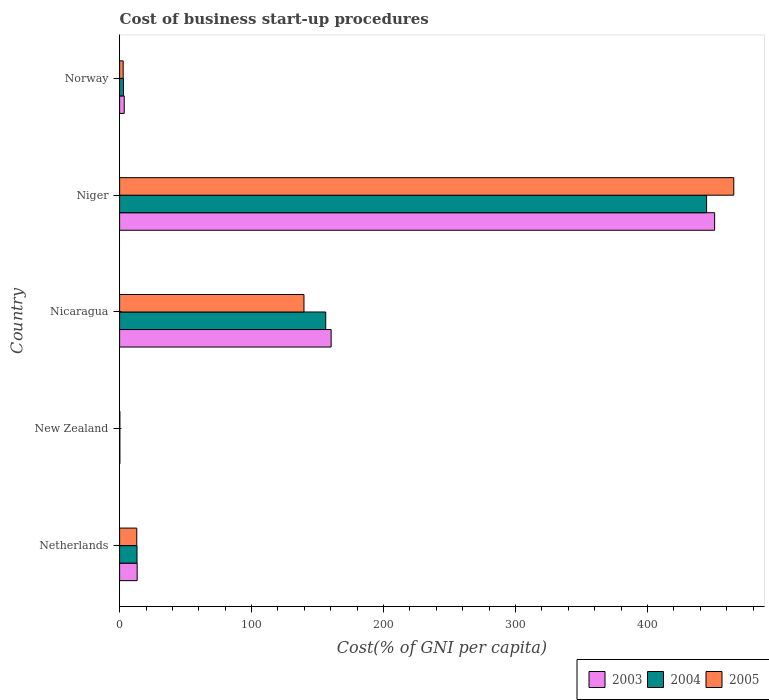How many groups of bars are there?
Make the answer very short. 5. Are the number of bars per tick equal to the number of legend labels?
Your answer should be very brief. Yes. How many bars are there on the 1st tick from the top?
Your answer should be very brief. 3. How many bars are there on the 5th tick from the bottom?
Provide a succinct answer. 3. What is the label of the 2nd group of bars from the top?
Your response must be concise. Niger. What is the cost of business start-up procedures in 2005 in Nicaragua?
Your answer should be compact. 139.7. Across all countries, what is the maximum cost of business start-up procedures in 2005?
Ensure brevity in your answer.  465.4. In which country was the cost of business start-up procedures in 2005 maximum?
Your answer should be compact. Niger. In which country was the cost of business start-up procedures in 2004 minimum?
Keep it short and to the point. New Zealand. What is the total cost of business start-up procedures in 2003 in the graph?
Give a very brief answer. 628.2. What is the difference between the cost of business start-up procedures in 2003 in Netherlands and that in Nicaragua?
Provide a short and direct response. -147. What is the difference between the cost of business start-up procedures in 2004 in New Zealand and the cost of business start-up procedures in 2005 in Nicaragua?
Provide a succinct answer. -139.5. What is the average cost of business start-up procedures in 2003 per country?
Make the answer very short. 125.64. What is the difference between the cost of business start-up procedures in 2003 and cost of business start-up procedures in 2005 in Norway?
Offer a very short reply. 0.8. What is the ratio of the cost of business start-up procedures in 2005 in Nicaragua to that in Norway?
Your response must be concise. 51.74. Is the cost of business start-up procedures in 2005 in Nicaragua less than that in Norway?
Offer a terse response. No. What is the difference between the highest and the second highest cost of business start-up procedures in 2005?
Make the answer very short. 325.7. What is the difference between the highest and the lowest cost of business start-up procedures in 2005?
Make the answer very short. 465.2. Is it the case that in every country, the sum of the cost of business start-up procedures in 2004 and cost of business start-up procedures in 2003 is greater than the cost of business start-up procedures in 2005?
Make the answer very short. Yes. How many bars are there?
Offer a very short reply. 15. What is the difference between two consecutive major ticks on the X-axis?
Offer a terse response. 100. Are the values on the major ticks of X-axis written in scientific E-notation?
Make the answer very short. No. Does the graph contain grids?
Your answer should be very brief. No. What is the title of the graph?
Provide a succinct answer. Cost of business start-up procedures. What is the label or title of the X-axis?
Give a very brief answer. Cost(% of GNI per capita). What is the label or title of the Y-axis?
Provide a succinct answer. Country. What is the Cost(% of GNI per capita) in 2003 in Netherlands?
Provide a succinct answer. 13.3. What is the Cost(% of GNI per capita) of 2003 in Nicaragua?
Ensure brevity in your answer.  160.3. What is the Cost(% of GNI per capita) of 2004 in Nicaragua?
Give a very brief answer. 156.2. What is the Cost(% of GNI per capita) in 2005 in Nicaragua?
Your answer should be very brief. 139.7. What is the Cost(% of GNI per capita) in 2003 in Niger?
Offer a terse response. 450.9. What is the Cost(% of GNI per capita) of 2004 in Niger?
Make the answer very short. 444.8. What is the Cost(% of GNI per capita) of 2005 in Niger?
Provide a short and direct response. 465.4. What is the Cost(% of GNI per capita) in 2003 in Norway?
Offer a very short reply. 3.5. Across all countries, what is the maximum Cost(% of GNI per capita) of 2003?
Ensure brevity in your answer.  450.9. Across all countries, what is the maximum Cost(% of GNI per capita) of 2004?
Your answer should be very brief. 444.8. Across all countries, what is the maximum Cost(% of GNI per capita) of 2005?
Your response must be concise. 465.4. Across all countries, what is the minimum Cost(% of GNI per capita) in 2003?
Offer a very short reply. 0.2. Across all countries, what is the minimum Cost(% of GNI per capita) in 2004?
Provide a short and direct response. 0.2. Across all countries, what is the minimum Cost(% of GNI per capita) in 2005?
Give a very brief answer. 0.2. What is the total Cost(% of GNI per capita) in 2003 in the graph?
Provide a short and direct response. 628.2. What is the total Cost(% of GNI per capita) of 2004 in the graph?
Your answer should be very brief. 617.3. What is the total Cost(% of GNI per capita) in 2005 in the graph?
Your answer should be compact. 621. What is the difference between the Cost(% of GNI per capita) in 2003 in Netherlands and that in New Zealand?
Your answer should be very brief. 13.1. What is the difference between the Cost(% of GNI per capita) of 2005 in Netherlands and that in New Zealand?
Offer a terse response. 12.8. What is the difference between the Cost(% of GNI per capita) of 2003 in Netherlands and that in Nicaragua?
Offer a very short reply. -147. What is the difference between the Cost(% of GNI per capita) of 2004 in Netherlands and that in Nicaragua?
Your answer should be compact. -143. What is the difference between the Cost(% of GNI per capita) of 2005 in Netherlands and that in Nicaragua?
Offer a very short reply. -126.7. What is the difference between the Cost(% of GNI per capita) in 2003 in Netherlands and that in Niger?
Make the answer very short. -437.6. What is the difference between the Cost(% of GNI per capita) in 2004 in Netherlands and that in Niger?
Your answer should be compact. -431.6. What is the difference between the Cost(% of GNI per capita) in 2005 in Netherlands and that in Niger?
Provide a succinct answer. -452.4. What is the difference between the Cost(% of GNI per capita) in 2004 in Netherlands and that in Norway?
Provide a succinct answer. 10.3. What is the difference between the Cost(% of GNI per capita) in 2003 in New Zealand and that in Nicaragua?
Your answer should be compact. -160.1. What is the difference between the Cost(% of GNI per capita) of 2004 in New Zealand and that in Nicaragua?
Make the answer very short. -156. What is the difference between the Cost(% of GNI per capita) in 2005 in New Zealand and that in Nicaragua?
Offer a very short reply. -139.5. What is the difference between the Cost(% of GNI per capita) of 2003 in New Zealand and that in Niger?
Your response must be concise. -450.7. What is the difference between the Cost(% of GNI per capita) of 2004 in New Zealand and that in Niger?
Give a very brief answer. -444.6. What is the difference between the Cost(% of GNI per capita) of 2005 in New Zealand and that in Niger?
Offer a very short reply. -465.2. What is the difference between the Cost(% of GNI per capita) in 2004 in New Zealand and that in Norway?
Your response must be concise. -2.7. What is the difference between the Cost(% of GNI per capita) in 2005 in New Zealand and that in Norway?
Keep it short and to the point. -2.5. What is the difference between the Cost(% of GNI per capita) of 2003 in Nicaragua and that in Niger?
Your response must be concise. -290.6. What is the difference between the Cost(% of GNI per capita) of 2004 in Nicaragua and that in Niger?
Offer a very short reply. -288.6. What is the difference between the Cost(% of GNI per capita) of 2005 in Nicaragua and that in Niger?
Your answer should be very brief. -325.7. What is the difference between the Cost(% of GNI per capita) of 2003 in Nicaragua and that in Norway?
Your answer should be very brief. 156.8. What is the difference between the Cost(% of GNI per capita) in 2004 in Nicaragua and that in Norway?
Offer a terse response. 153.3. What is the difference between the Cost(% of GNI per capita) in 2005 in Nicaragua and that in Norway?
Provide a succinct answer. 137. What is the difference between the Cost(% of GNI per capita) in 2003 in Niger and that in Norway?
Give a very brief answer. 447.4. What is the difference between the Cost(% of GNI per capita) of 2004 in Niger and that in Norway?
Make the answer very short. 441.9. What is the difference between the Cost(% of GNI per capita) of 2005 in Niger and that in Norway?
Your answer should be compact. 462.7. What is the difference between the Cost(% of GNI per capita) in 2003 in Netherlands and the Cost(% of GNI per capita) in 2004 in New Zealand?
Your answer should be very brief. 13.1. What is the difference between the Cost(% of GNI per capita) in 2003 in Netherlands and the Cost(% of GNI per capita) in 2004 in Nicaragua?
Keep it short and to the point. -142.9. What is the difference between the Cost(% of GNI per capita) of 2003 in Netherlands and the Cost(% of GNI per capita) of 2005 in Nicaragua?
Provide a succinct answer. -126.4. What is the difference between the Cost(% of GNI per capita) in 2004 in Netherlands and the Cost(% of GNI per capita) in 2005 in Nicaragua?
Offer a terse response. -126.5. What is the difference between the Cost(% of GNI per capita) of 2003 in Netherlands and the Cost(% of GNI per capita) of 2004 in Niger?
Provide a short and direct response. -431.5. What is the difference between the Cost(% of GNI per capita) in 2003 in Netherlands and the Cost(% of GNI per capita) in 2005 in Niger?
Offer a very short reply. -452.1. What is the difference between the Cost(% of GNI per capita) of 2004 in Netherlands and the Cost(% of GNI per capita) of 2005 in Niger?
Make the answer very short. -452.2. What is the difference between the Cost(% of GNI per capita) of 2003 in Netherlands and the Cost(% of GNI per capita) of 2004 in Norway?
Ensure brevity in your answer.  10.4. What is the difference between the Cost(% of GNI per capita) of 2003 in New Zealand and the Cost(% of GNI per capita) of 2004 in Nicaragua?
Provide a short and direct response. -156. What is the difference between the Cost(% of GNI per capita) of 2003 in New Zealand and the Cost(% of GNI per capita) of 2005 in Nicaragua?
Your answer should be very brief. -139.5. What is the difference between the Cost(% of GNI per capita) of 2004 in New Zealand and the Cost(% of GNI per capita) of 2005 in Nicaragua?
Your answer should be compact. -139.5. What is the difference between the Cost(% of GNI per capita) in 2003 in New Zealand and the Cost(% of GNI per capita) in 2004 in Niger?
Make the answer very short. -444.6. What is the difference between the Cost(% of GNI per capita) of 2003 in New Zealand and the Cost(% of GNI per capita) of 2005 in Niger?
Offer a terse response. -465.2. What is the difference between the Cost(% of GNI per capita) in 2004 in New Zealand and the Cost(% of GNI per capita) in 2005 in Niger?
Your response must be concise. -465.2. What is the difference between the Cost(% of GNI per capita) of 2003 in Nicaragua and the Cost(% of GNI per capita) of 2004 in Niger?
Your answer should be compact. -284.5. What is the difference between the Cost(% of GNI per capita) of 2003 in Nicaragua and the Cost(% of GNI per capita) of 2005 in Niger?
Your answer should be very brief. -305.1. What is the difference between the Cost(% of GNI per capita) of 2004 in Nicaragua and the Cost(% of GNI per capita) of 2005 in Niger?
Make the answer very short. -309.2. What is the difference between the Cost(% of GNI per capita) of 2003 in Nicaragua and the Cost(% of GNI per capita) of 2004 in Norway?
Offer a very short reply. 157.4. What is the difference between the Cost(% of GNI per capita) in 2003 in Nicaragua and the Cost(% of GNI per capita) in 2005 in Norway?
Give a very brief answer. 157.6. What is the difference between the Cost(% of GNI per capita) of 2004 in Nicaragua and the Cost(% of GNI per capita) of 2005 in Norway?
Keep it short and to the point. 153.5. What is the difference between the Cost(% of GNI per capita) of 2003 in Niger and the Cost(% of GNI per capita) of 2004 in Norway?
Your answer should be very brief. 448. What is the difference between the Cost(% of GNI per capita) of 2003 in Niger and the Cost(% of GNI per capita) of 2005 in Norway?
Your response must be concise. 448.2. What is the difference between the Cost(% of GNI per capita) in 2004 in Niger and the Cost(% of GNI per capita) in 2005 in Norway?
Make the answer very short. 442.1. What is the average Cost(% of GNI per capita) of 2003 per country?
Offer a very short reply. 125.64. What is the average Cost(% of GNI per capita) of 2004 per country?
Keep it short and to the point. 123.46. What is the average Cost(% of GNI per capita) in 2005 per country?
Provide a succinct answer. 124.2. What is the difference between the Cost(% of GNI per capita) of 2003 and Cost(% of GNI per capita) of 2004 in Netherlands?
Provide a short and direct response. 0.1. What is the difference between the Cost(% of GNI per capita) in 2003 and Cost(% of GNI per capita) in 2005 in Netherlands?
Give a very brief answer. 0.3. What is the difference between the Cost(% of GNI per capita) in 2004 and Cost(% of GNI per capita) in 2005 in Netherlands?
Offer a terse response. 0.2. What is the difference between the Cost(% of GNI per capita) of 2003 and Cost(% of GNI per capita) of 2004 in New Zealand?
Provide a succinct answer. 0. What is the difference between the Cost(% of GNI per capita) in 2003 and Cost(% of GNI per capita) in 2004 in Nicaragua?
Provide a succinct answer. 4.1. What is the difference between the Cost(% of GNI per capita) in 2003 and Cost(% of GNI per capita) in 2005 in Nicaragua?
Make the answer very short. 20.6. What is the difference between the Cost(% of GNI per capita) in 2004 and Cost(% of GNI per capita) in 2005 in Nicaragua?
Offer a terse response. 16.5. What is the difference between the Cost(% of GNI per capita) in 2003 and Cost(% of GNI per capita) in 2004 in Niger?
Provide a succinct answer. 6.1. What is the difference between the Cost(% of GNI per capita) in 2003 and Cost(% of GNI per capita) in 2005 in Niger?
Your answer should be very brief. -14.5. What is the difference between the Cost(% of GNI per capita) in 2004 and Cost(% of GNI per capita) in 2005 in Niger?
Your response must be concise. -20.6. What is the difference between the Cost(% of GNI per capita) of 2003 and Cost(% of GNI per capita) of 2004 in Norway?
Your answer should be very brief. 0.6. What is the difference between the Cost(% of GNI per capita) in 2003 and Cost(% of GNI per capita) in 2005 in Norway?
Offer a very short reply. 0.8. What is the difference between the Cost(% of GNI per capita) of 2004 and Cost(% of GNI per capita) of 2005 in Norway?
Your answer should be compact. 0.2. What is the ratio of the Cost(% of GNI per capita) in 2003 in Netherlands to that in New Zealand?
Provide a short and direct response. 66.5. What is the ratio of the Cost(% of GNI per capita) of 2004 in Netherlands to that in New Zealand?
Provide a succinct answer. 66. What is the ratio of the Cost(% of GNI per capita) in 2003 in Netherlands to that in Nicaragua?
Your answer should be very brief. 0.08. What is the ratio of the Cost(% of GNI per capita) in 2004 in Netherlands to that in Nicaragua?
Keep it short and to the point. 0.08. What is the ratio of the Cost(% of GNI per capita) of 2005 in Netherlands to that in Nicaragua?
Your response must be concise. 0.09. What is the ratio of the Cost(% of GNI per capita) of 2003 in Netherlands to that in Niger?
Make the answer very short. 0.03. What is the ratio of the Cost(% of GNI per capita) of 2004 in Netherlands to that in Niger?
Offer a terse response. 0.03. What is the ratio of the Cost(% of GNI per capita) of 2005 in Netherlands to that in Niger?
Ensure brevity in your answer.  0.03. What is the ratio of the Cost(% of GNI per capita) in 2003 in Netherlands to that in Norway?
Provide a short and direct response. 3.8. What is the ratio of the Cost(% of GNI per capita) in 2004 in Netherlands to that in Norway?
Ensure brevity in your answer.  4.55. What is the ratio of the Cost(% of GNI per capita) in 2005 in Netherlands to that in Norway?
Offer a terse response. 4.81. What is the ratio of the Cost(% of GNI per capita) in 2003 in New Zealand to that in Nicaragua?
Make the answer very short. 0. What is the ratio of the Cost(% of GNI per capita) of 2004 in New Zealand to that in Nicaragua?
Ensure brevity in your answer.  0. What is the ratio of the Cost(% of GNI per capita) in 2005 in New Zealand to that in Nicaragua?
Make the answer very short. 0. What is the ratio of the Cost(% of GNI per capita) of 2004 in New Zealand to that in Niger?
Offer a very short reply. 0. What is the ratio of the Cost(% of GNI per capita) in 2005 in New Zealand to that in Niger?
Give a very brief answer. 0. What is the ratio of the Cost(% of GNI per capita) in 2003 in New Zealand to that in Norway?
Provide a succinct answer. 0.06. What is the ratio of the Cost(% of GNI per capita) in 2004 in New Zealand to that in Norway?
Your response must be concise. 0.07. What is the ratio of the Cost(% of GNI per capita) in 2005 in New Zealand to that in Norway?
Keep it short and to the point. 0.07. What is the ratio of the Cost(% of GNI per capita) in 2003 in Nicaragua to that in Niger?
Offer a terse response. 0.36. What is the ratio of the Cost(% of GNI per capita) in 2004 in Nicaragua to that in Niger?
Keep it short and to the point. 0.35. What is the ratio of the Cost(% of GNI per capita) in 2005 in Nicaragua to that in Niger?
Offer a very short reply. 0.3. What is the ratio of the Cost(% of GNI per capita) of 2003 in Nicaragua to that in Norway?
Make the answer very short. 45.8. What is the ratio of the Cost(% of GNI per capita) in 2004 in Nicaragua to that in Norway?
Keep it short and to the point. 53.86. What is the ratio of the Cost(% of GNI per capita) in 2005 in Nicaragua to that in Norway?
Ensure brevity in your answer.  51.74. What is the ratio of the Cost(% of GNI per capita) in 2003 in Niger to that in Norway?
Ensure brevity in your answer.  128.83. What is the ratio of the Cost(% of GNI per capita) in 2004 in Niger to that in Norway?
Your answer should be very brief. 153.38. What is the ratio of the Cost(% of GNI per capita) of 2005 in Niger to that in Norway?
Ensure brevity in your answer.  172.37. What is the difference between the highest and the second highest Cost(% of GNI per capita) in 2003?
Offer a terse response. 290.6. What is the difference between the highest and the second highest Cost(% of GNI per capita) of 2004?
Your answer should be compact. 288.6. What is the difference between the highest and the second highest Cost(% of GNI per capita) in 2005?
Provide a succinct answer. 325.7. What is the difference between the highest and the lowest Cost(% of GNI per capita) of 2003?
Offer a very short reply. 450.7. What is the difference between the highest and the lowest Cost(% of GNI per capita) of 2004?
Offer a terse response. 444.6. What is the difference between the highest and the lowest Cost(% of GNI per capita) of 2005?
Your response must be concise. 465.2. 